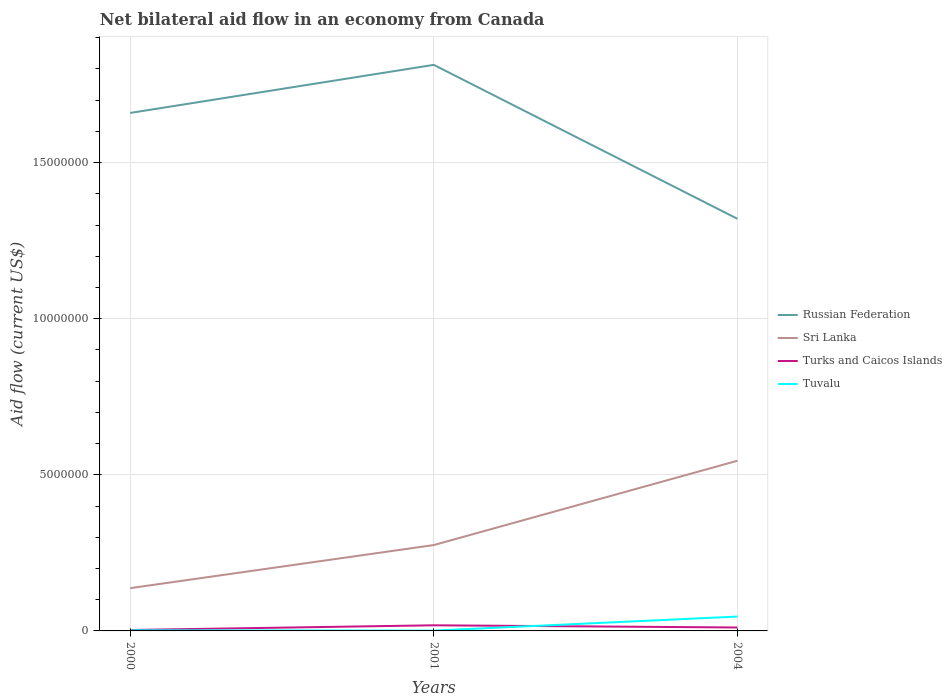How many different coloured lines are there?
Ensure brevity in your answer.  4. Does the line corresponding to Turks and Caicos Islands intersect with the line corresponding to Sri Lanka?
Your answer should be compact. No. In which year was the net bilateral aid flow in Russian Federation maximum?
Your answer should be compact. 2004. What is the total net bilateral aid flow in Sri Lanka in the graph?
Your answer should be very brief. -4.08e+06. How many lines are there?
Give a very brief answer. 4. What is the difference between two consecutive major ticks on the Y-axis?
Provide a succinct answer. 5.00e+06. Does the graph contain any zero values?
Your answer should be very brief. No. How are the legend labels stacked?
Provide a succinct answer. Vertical. What is the title of the graph?
Offer a terse response. Net bilateral aid flow in an economy from Canada. What is the label or title of the X-axis?
Offer a terse response. Years. What is the label or title of the Y-axis?
Offer a terse response. Aid flow (current US$). What is the Aid flow (current US$) in Russian Federation in 2000?
Your answer should be very brief. 1.66e+07. What is the Aid flow (current US$) in Sri Lanka in 2000?
Give a very brief answer. 1.37e+06. What is the Aid flow (current US$) in Turks and Caicos Islands in 2000?
Your response must be concise. 3.00e+04. What is the Aid flow (current US$) of Russian Federation in 2001?
Provide a succinct answer. 1.81e+07. What is the Aid flow (current US$) of Sri Lanka in 2001?
Give a very brief answer. 2.75e+06. What is the Aid flow (current US$) of Turks and Caicos Islands in 2001?
Your answer should be very brief. 1.80e+05. What is the Aid flow (current US$) in Tuvalu in 2001?
Keep it short and to the point. 10000. What is the Aid flow (current US$) of Russian Federation in 2004?
Ensure brevity in your answer.  1.32e+07. What is the Aid flow (current US$) of Sri Lanka in 2004?
Ensure brevity in your answer.  5.45e+06. What is the Aid flow (current US$) in Tuvalu in 2004?
Your answer should be very brief. 4.60e+05. Across all years, what is the maximum Aid flow (current US$) in Russian Federation?
Offer a terse response. 1.81e+07. Across all years, what is the maximum Aid flow (current US$) in Sri Lanka?
Offer a terse response. 5.45e+06. Across all years, what is the maximum Aid flow (current US$) in Tuvalu?
Provide a short and direct response. 4.60e+05. Across all years, what is the minimum Aid flow (current US$) of Russian Federation?
Keep it short and to the point. 1.32e+07. Across all years, what is the minimum Aid flow (current US$) in Sri Lanka?
Provide a succinct answer. 1.37e+06. Across all years, what is the minimum Aid flow (current US$) in Tuvalu?
Give a very brief answer. 10000. What is the total Aid flow (current US$) in Russian Federation in the graph?
Ensure brevity in your answer.  4.79e+07. What is the total Aid flow (current US$) in Sri Lanka in the graph?
Make the answer very short. 9.57e+06. What is the total Aid flow (current US$) of Turks and Caicos Islands in the graph?
Provide a short and direct response. 3.20e+05. What is the difference between the Aid flow (current US$) in Russian Federation in 2000 and that in 2001?
Ensure brevity in your answer.  -1.54e+06. What is the difference between the Aid flow (current US$) in Sri Lanka in 2000 and that in 2001?
Offer a very short reply. -1.38e+06. What is the difference between the Aid flow (current US$) in Turks and Caicos Islands in 2000 and that in 2001?
Offer a terse response. -1.50e+05. What is the difference between the Aid flow (current US$) in Tuvalu in 2000 and that in 2001?
Provide a short and direct response. 10000. What is the difference between the Aid flow (current US$) in Russian Federation in 2000 and that in 2004?
Your response must be concise. 3.39e+06. What is the difference between the Aid flow (current US$) in Sri Lanka in 2000 and that in 2004?
Your answer should be compact. -4.08e+06. What is the difference between the Aid flow (current US$) of Tuvalu in 2000 and that in 2004?
Your answer should be compact. -4.40e+05. What is the difference between the Aid flow (current US$) in Russian Federation in 2001 and that in 2004?
Provide a short and direct response. 4.93e+06. What is the difference between the Aid flow (current US$) in Sri Lanka in 2001 and that in 2004?
Your answer should be compact. -2.70e+06. What is the difference between the Aid flow (current US$) of Tuvalu in 2001 and that in 2004?
Your answer should be compact. -4.50e+05. What is the difference between the Aid flow (current US$) in Russian Federation in 2000 and the Aid flow (current US$) in Sri Lanka in 2001?
Ensure brevity in your answer.  1.38e+07. What is the difference between the Aid flow (current US$) of Russian Federation in 2000 and the Aid flow (current US$) of Turks and Caicos Islands in 2001?
Your answer should be very brief. 1.64e+07. What is the difference between the Aid flow (current US$) of Russian Federation in 2000 and the Aid flow (current US$) of Tuvalu in 2001?
Your answer should be compact. 1.66e+07. What is the difference between the Aid flow (current US$) of Sri Lanka in 2000 and the Aid flow (current US$) of Turks and Caicos Islands in 2001?
Offer a terse response. 1.19e+06. What is the difference between the Aid flow (current US$) of Sri Lanka in 2000 and the Aid flow (current US$) of Tuvalu in 2001?
Ensure brevity in your answer.  1.36e+06. What is the difference between the Aid flow (current US$) in Russian Federation in 2000 and the Aid flow (current US$) in Sri Lanka in 2004?
Make the answer very short. 1.11e+07. What is the difference between the Aid flow (current US$) in Russian Federation in 2000 and the Aid flow (current US$) in Turks and Caicos Islands in 2004?
Your response must be concise. 1.65e+07. What is the difference between the Aid flow (current US$) of Russian Federation in 2000 and the Aid flow (current US$) of Tuvalu in 2004?
Your answer should be very brief. 1.61e+07. What is the difference between the Aid flow (current US$) in Sri Lanka in 2000 and the Aid flow (current US$) in Turks and Caicos Islands in 2004?
Offer a very short reply. 1.26e+06. What is the difference between the Aid flow (current US$) of Sri Lanka in 2000 and the Aid flow (current US$) of Tuvalu in 2004?
Your response must be concise. 9.10e+05. What is the difference between the Aid flow (current US$) in Turks and Caicos Islands in 2000 and the Aid flow (current US$) in Tuvalu in 2004?
Provide a succinct answer. -4.30e+05. What is the difference between the Aid flow (current US$) of Russian Federation in 2001 and the Aid flow (current US$) of Sri Lanka in 2004?
Your answer should be compact. 1.27e+07. What is the difference between the Aid flow (current US$) of Russian Federation in 2001 and the Aid flow (current US$) of Turks and Caicos Islands in 2004?
Offer a terse response. 1.80e+07. What is the difference between the Aid flow (current US$) in Russian Federation in 2001 and the Aid flow (current US$) in Tuvalu in 2004?
Offer a terse response. 1.77e+07. What is the difference between the Aid flow (current US$) in Sri Lanka in 2001 and the Aid flow (current US$) in Turks and Caicos Islands in 2004?
Provide a short and direct response. 2.64e+06. What is the difference between the Aid flow (current US$) in Sri Lanka in 2001 and the Aid flow (current US$) in Tuvalu in 2004?
Make the answer very short. 2.29e+06. What is the difference between the Aid flow (current US$) of Turks and Caicos Islands in 2001 and the Aid flow (current US$) of Tuvalu in 2004?
Provide a short and direct response. -2.80e+05. What is the average Aid flow (current US$) in Russian Federation per year?
Make the answer very short. 1.60e+07. What is the average Aid flow (current US$) in Sri Lanka per year?
Provide a succinct answer. 3.19e+06. What is the average Aid flow (current US$) of Turks and Caicos Islands per year?
Give a very brief answer. 1.07e+05. What is the average Aid flow (current US$) in Tuvalu per year?
Ensure brevity in your answer.  1.63e+05. In the year 2000, what is the difference between the Aid flow (current US$) of Russian Federation and Aid flow (current US$) of Sri Lanka?
Offer a terse response. 1.52e+07. In the year 2000, what is the difference between the Aid flow (current US$) of Russian Federation and Aid flow (current US$) of Turks and Caicos Islands?
Ensure brevity in your answer.  1.66e+07. In the year 2000, what is the difference between the Aid flow (current US$) of Russian Federation and Aid flow (current US$) of Tuvalu?
Offer a terse response. 1.66e+07. In the year 2000, what is the difference between the Aid flow (current US$) in Sri Lanka and Aid flow (current US$) in Turks and Caicos Islands?
Keep it short and to the point. 1.34e+06. In the year 2000, what is the difference between the Aid flow (current US$) in Sri Lanka and Aid flow (current US$) in Tuvalu?
Your answer should be compact. 1.35e+06. In the year 2000, what is the difference between the Aid flow (current US$) in Turks and Caicos Islands and Aid flow (current US$) in Tuvalu?
Provide a short and direct response. 10000. In the year 2001, what is the difference between the Aid flow (current US$) of Russian Federation and Aid flow (current US$) of Sri Lanka?
Ensure brevity in your answer.  1.54e+07. In the year 2001, what is the difference between the Aid flow (current US$) in Russian Federation and Aid flow (current US$) in Turks and Caicos Islands?
Make the answer very short. 1.80e+07. In the year 2001, what is the difference between the Aid flow (current US$) in Russian Federation and Aid flow (current US$) in Tuvalu?
Offer a terse response. 1.81e+07. In the year 2001, what is the difference between the Aid flow (current US$) in Sri Lanka and Aid flow (current US$) in Turks and Caicos Islands?
Give a very brief answer. 2.57e+06. In the year 2001, what is the difference between the Aid flow (current US$) in Sri Lanka and Aid flow (current US$) in Tuvalu?
Ensure brevity in your answer.  2.74e+06. In the year 2004, what is the difference between the Aid flow (current US$) in Russian Federation and Aid flow (current US$) in Sri Lanka?
Make the answer very short. 7.75e+06. In the year 2004, what is the difference between the Aid flow (current US$) in Russian Federation and Aid flow (current US$) in Turks and Caicos Islands?
Make the answer very short. 1.31e+07. In the year 2004, what is the difference between the Aid flow (current US$) in Russian Federation and Aid flow (current US$) in Tuvalu?
Provide a succinct answer. 1.27e+07. In the year 2004, what is the difference between the Aid flow (current US$) in Sri Lanka and Aid flow (current US$) in Turks and Caicos Islands?
Make the answer very short. 5.34e+06. In the year 2004, what is the difference between the Aid flow (current US$) of Sri Lanka and Aid flow (current US$) of Tuvalu?
Your answer should be very brief. 4.99e+06. In the year 2004, what is the difference between the Aid flow (current US$) of Turks and Caicos Islands and Aid flow (current US$) of Tuvalu?
Offer a very short reply. -3.50e+05. What is the ratio of the Aid flow (current US$) of Russian Federation in 2000 to that in 2001?
Ensure brevity in your answer.  0.92. What is the ratio of the Aid flow (current US$) in Sri Lanka in 2000 to that in 2001?
Keep it short and to the point. 0.5. What is the ratio of the Aid flow (current US$) of Turks and Caicos Islands in 2000 to that in 2001?
Make the answer very short. 0.17. What is the ratio of the Aid flow (current US$) in Russian Federation in 2000 to that in 2004?
Make the answer very short. 1.26. What is the ratio of the Aid flow (current US$) of Sri Lanka in 2000 to that in 2004?
Provide a short and direct response. 0.25. What is the ratio of the Aid flow (current US$) of Turks and Caicos Islands in 2000 to that in 2004?
Provide a succinct answer. 0.27. What is the ratio of the Aid flow (current US$) of Tuvalu in 2000 to that in 2004?
Your response must be concise. 0.04. What is the ratio of the Aid flow (current US$) of Russian Federation in 2001 to that in 2004?
Give a very brief answer. 1.37. What is the ratio of the Aid flow (current US$) of Sri Lanka in 2001 to that in 2004?
Your answer should be compact. 0.5. What is the ratio of the Aid flow (current US$) in Turks and Caicos Islands in 2001 to that in 2004?
Make the answer very short. 1.64. What is the ratio of the Aid flow (current US$) of Tuvalu in 2001 to that in 2004?
Your answer should be compact. 0.02. What is the difference between the highest and the second highest Aid flow (current US$) in Russian Federation?
Your answer should be very brief. 1.54e+06. What is the difference between the highest and the second highest Aid flow (current US$) in Sri Lanka?
Give a very brief answer. 2.70e+06. What is the difference between the highest and the second highest Aid flow (current US$) in Tuvalu?
Your answer should be compact. 4.40e+05. What is the difference between the highest and the lowest Aid flow (current US$) in Russian Federation?
Offer a very short reply. 4.93e+06. What is the difference between the highest and the lowest Aid flow (current US$) in Sri Lanka?
Your response must be concise. 4.08e+06. What is the difference between the highest and the lowest Aid flow (current US$) of Turks and Caicos Islands?
Offer a very short reply. 1.50e+05. What is the difference between the highest and the lowest Aid flow (current US$) in Tuvalu?
Offer a terse response. 4.50e+05. 